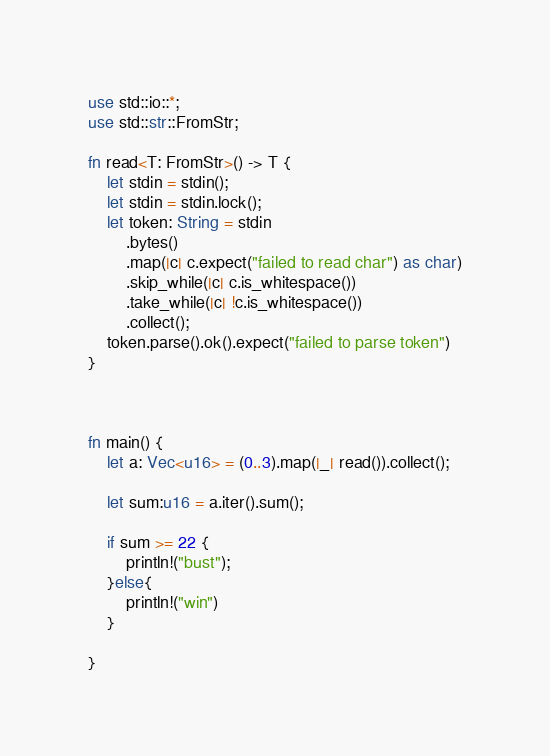<code> <loc_0><loc_0><loc_500><loc_500><_Rust_>use std::io::*;
use std::str::FromStr;

fn read<T: FromStr>() -> T {
    let stdin = stdin();
    let stdin = stdin.lock();
    let token: String = stdin
        .bytes()
        .map(|c| c.expect("failed to read char") as char)
        .skip_while(|c| c.is_whitespace())
        .take_while(|c| !c.is_whitespace())
        .collect();
    token.parse().ok().expect("failed to parse token")
}



fn main() {
    let a: Vec<u16> = (0..3).map(|_| read()).collect();

    let sum:u16 = a.iter().sum();

    if sum >= 22 {
        println!("bust");
    }else{
        println!("win")
    }
    
}
</code> 